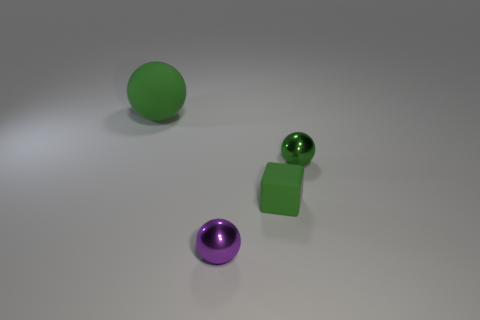What number of objects are behind the small purple metallic ball that is in front of the big green matte sphere?
Ensure brevity in your answer.  3. There is a tiny thing that is to the left of the green rubber object to the right of the small ball that is on the left side of the tiny green metal ball; what shape is it?
Offer a terse response. Sphere. How big is the green metallic thing?
Provide a succinct answer. Small. Are there any other big balls that have the same material as the purple ball?
Provide a short and direct response. No. The purple shiny thing that is the same shape as the small green metal thing is what size?
Offer a terse response. Small. Are there the same number of tiny green blocks that are in front of the large ball and purple metallic balls?
Your response must be concise. Yes. There is a shiny thing that is behind the small rubber thing; is its shape the same as the large rubber object?
Your answer should be compact. Yes. What is the shape of the large rubber thing?
Give a very brief answer. Sphere. What is the material of the tiny green object in front of the small object that is to the right of the green matte thing in front of the big object?
Offer a terse response. Rubber. What material is the large sphere that is the same color as the tiny rubber cube?
Offer a terse response. Rubber. 